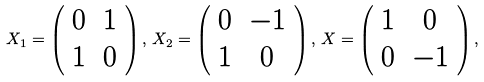<formula> <loc_0><loc_0><loc_500><loc_500>X _ { 1 } = \left ( \begin{array} { c c } 0 & 1 \\ 1 & 0 \end{array} \right ) , \, X _ { 2 } = \left ( \begin{array} { c c } 0 & - 1 \\ 1 & 0 \end{array} \right ) , \, X = \left ( \begin{array} { c c } 1 & 0 \\ 0 & - 1 \end{array} \right ) ,</formula> 